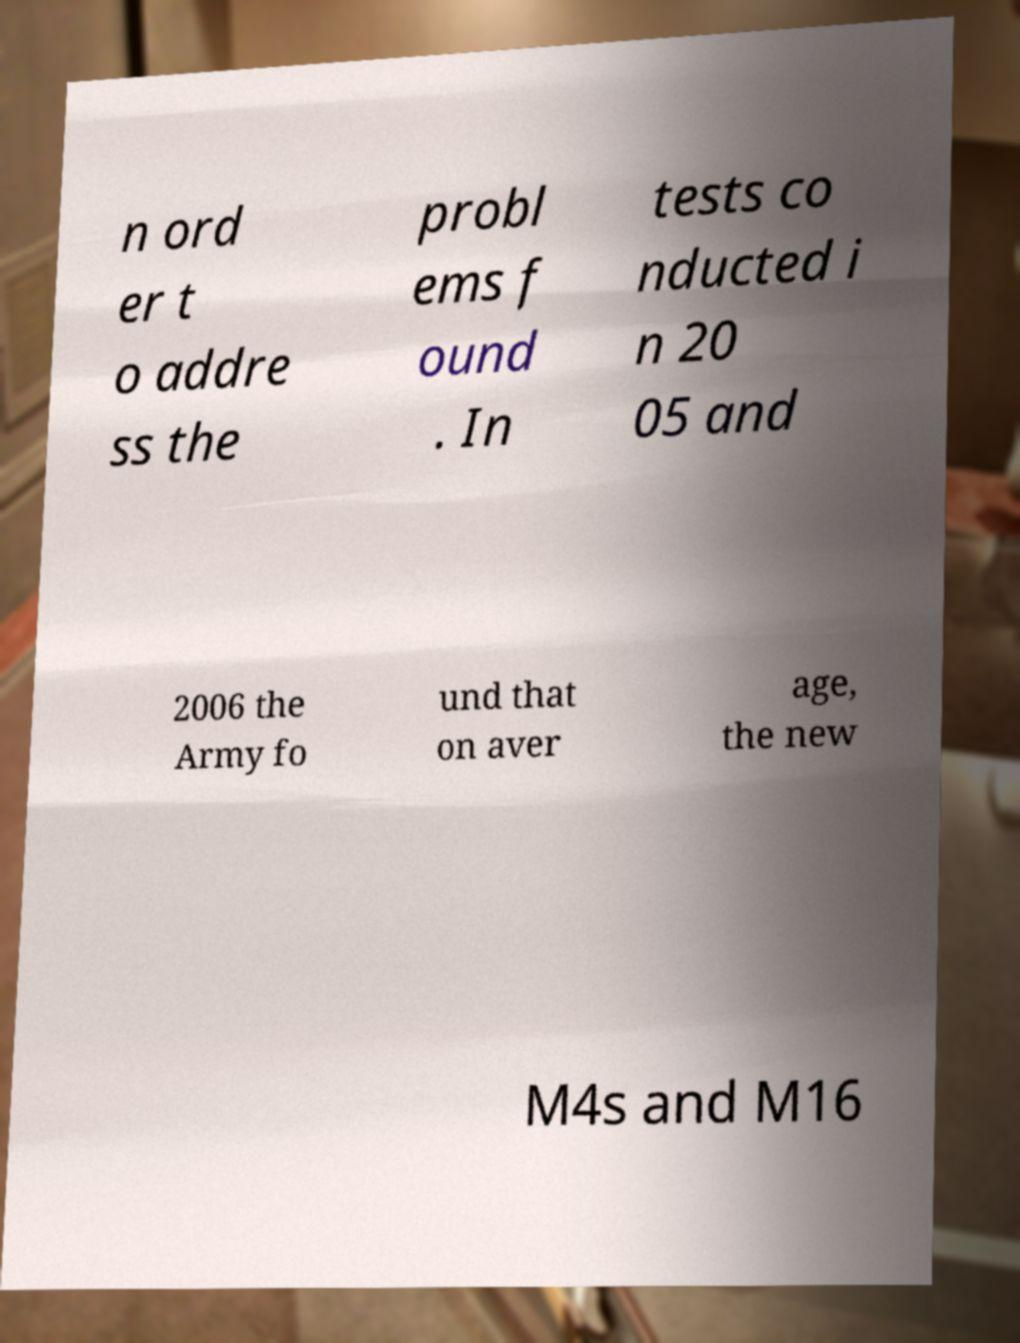For documentation purposes, I need the text within this image transcribed. Could you provide that? n ord er t o addre ss the probl ems f ound . In tests co nducted i n 20 05 and 2006 the Army fo und that on aver age, the new M4s and M16 